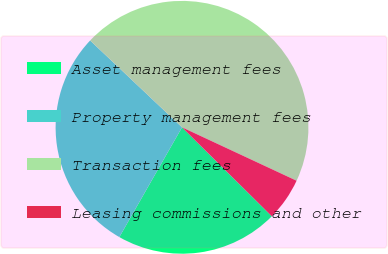Convert chart to OTSL. <chart><loc_0><loc_0><loc_500><loc_500><pie_chart><fcel>Asset management fees<fcel>Property management fees<fcel>Transaction fees<fcel>Leasing commissions and other<nl><fcel>20.83%<fcel>28.79%<fcel>44.89%<fcel>5.48%<nl></chart> 